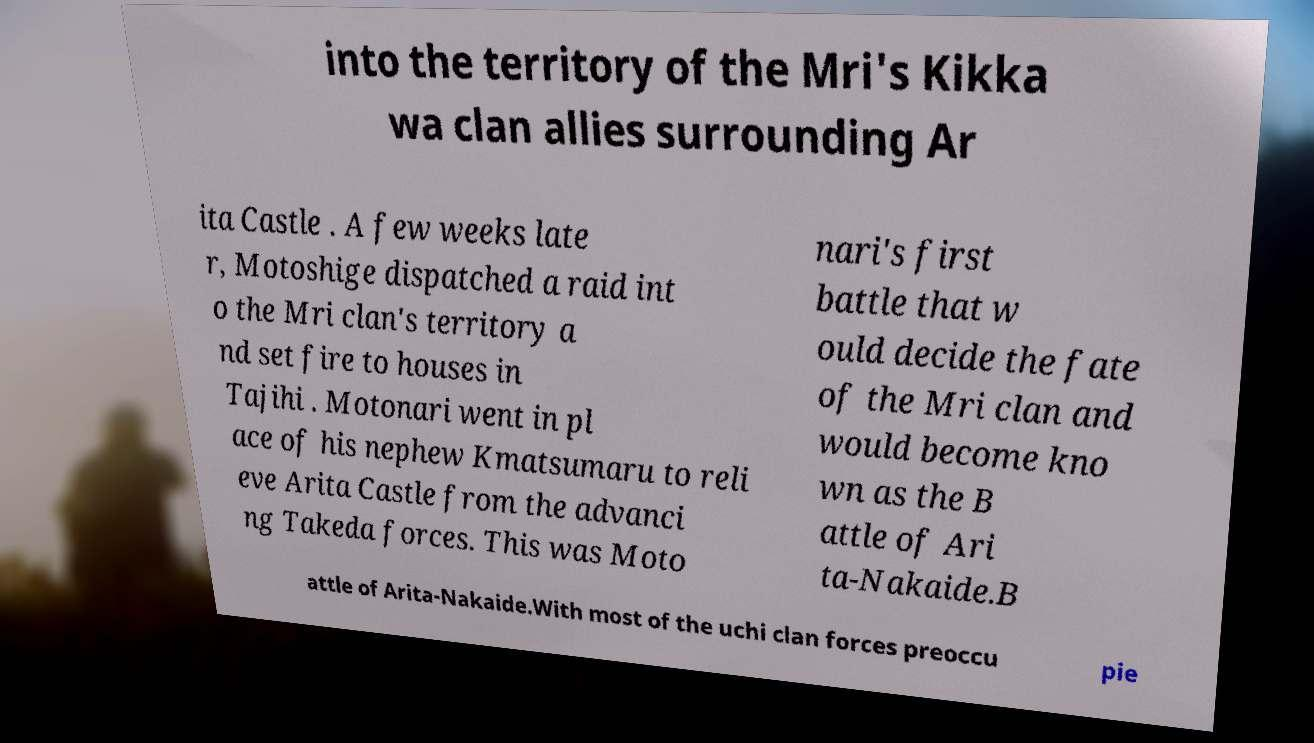For documentation purposes, I need the text within this image transcribed. Could you provide that? into the territory of the Mri's Kikka wa clan allies surrounding Ar ita Castle . A few weeks late r, Motoshige dispatched a raid int o the Mri clan's territory a nd set fire to houses in Tajihi . Motonari went in pl ace of his nephew Kmatsumaru to reli eve Arita Castle from the advanci ng Takeda forces. This was Moto nari's first battle that w ould decide the fate of the Mri clan and would become kno wn as the B attle of Ari ta-Nakaide.B attle of Arita-Nakaide.With most of the uchi clan forces preoccu pie 